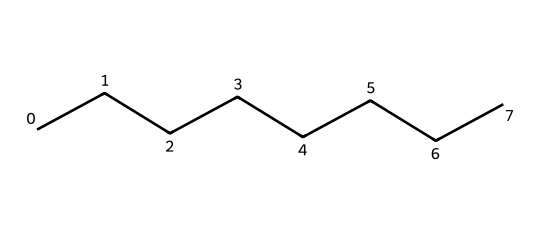What is the name of this chemical? The SMILES representation indicates a straight-chain alkane with eight carbon atoms. The common name for such a hydrocarbon is "octane."
Answer: octane How many carbon atoms are in the structure? By counting the 'C' characters in the SMILES string, there are a total of eight 'C's representing eight carbon atoms.
Answer: eight What is the number of hydrogen atoms in this chemical? In a straight-chain alkane, the number of hydrogen atoms can be calculated using the formula CnH(2n+2). Here, n=8, so H = 2(8) + 2 = 18.
Answer: eighteen Is this chemical a solid, liquid, or gas at room temperature? Naphtha, comprised mainly of alkanes like octane, is a liquid at room temperature due to its low boiling point relative to higher alkanes.
Answer: liquid Why is this chemical considered flammable? This chemical has a low flash point due to the presence of its volatile components, which means it can vaporize easily and ignite at room temperature.
Answer: low flash point What kind of reactions can naphtha undergo? Naphtha can undergo combustion reactions due to its flammable properties, producing heat, carbon dioxide, and water vapor upon burning.
Answer: combustion What is the main use of naphtha historically in lamps? Naphtha has been historically used as a lamp fuel due to its ability to produce a bright flame when burned.
Answer: lamp fuel 